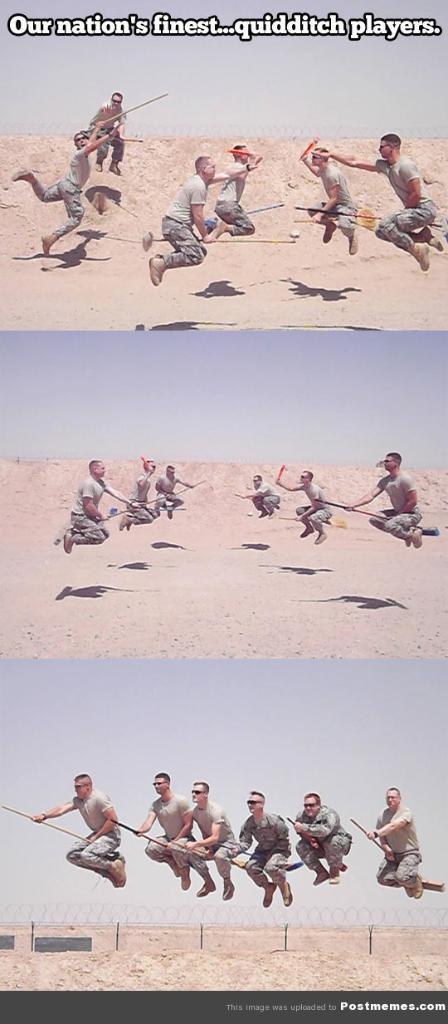What kind of players are featured?
Your answer should be very brief. Quidditch. What is wrote at the top?
Provide a short and direct response. Our nation's finest quidditch players. 